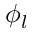Convert formula to latex. <formula><loc_0><loc_0><loc_500><loc_500>\phi _ { l }</formula> 